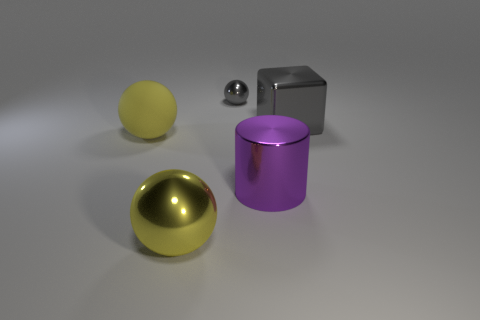What is the color of the shiny sphere behind the big metal thing that is to the left of the gray object that is behind the large metallic block?
Provide a short and direct response. Gray. Is the material of the tiny ball the same as the cylinder?
Your response must be concise. Yes. Is there a yellow rubber ball of the same size as the purple shiny thing?
Ensure brevity in your answer.  Yes. There is a cylinder that is the same size as the cube; what is its material?
Offer a very short reply. Metal. Are there any blue rubber objects that have the same shape as the large gray thing?
Provide a short and direct response. No. There is a object that is the same color as the large metal cube; what is it made of?
Offer a very short reply. Metal. What shape is the purple metal thing that is on the left side of the big gray thing?
Make the answer very short. Cylinder. How many big purple cylinders are there?
Ensure brevity in your answer.  1. What color is the tiny thing that is the same material as the gray cube?
Offer a terse response. Gray. How many tiny things are yellow balls or purple cylinders?
Your answer should be very brief. 0. 